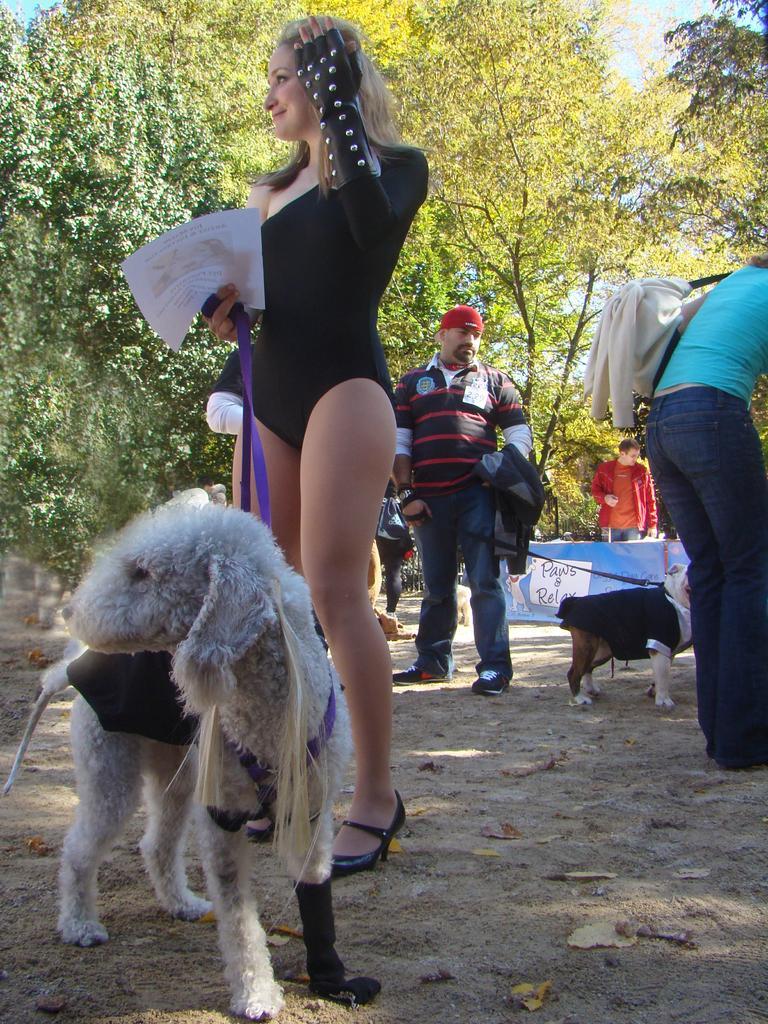Describe this image in one or two sentences. this is a picture in which there are group of people,in which a woman is holding a belt of a dog,here there are another man holding the dog,we can see many trees over here , we can also see the sky. 